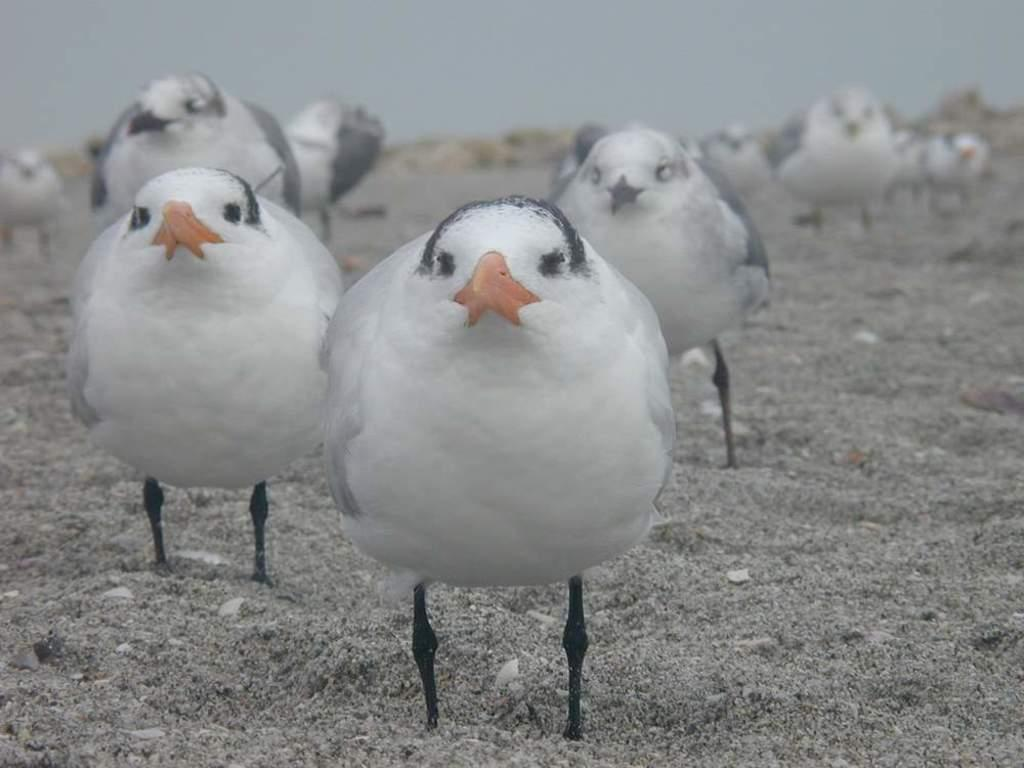What type of animals are on the ground in the image? There are birds on the ground in the image. What part of the natural environment is visible in the background of the image? The sky is visible in the background of the image. What type of ducks can be seen swimming in the harbor in the image? There are no ducks or harbor present in the image; it features birds on the ground and the sky in the background. 